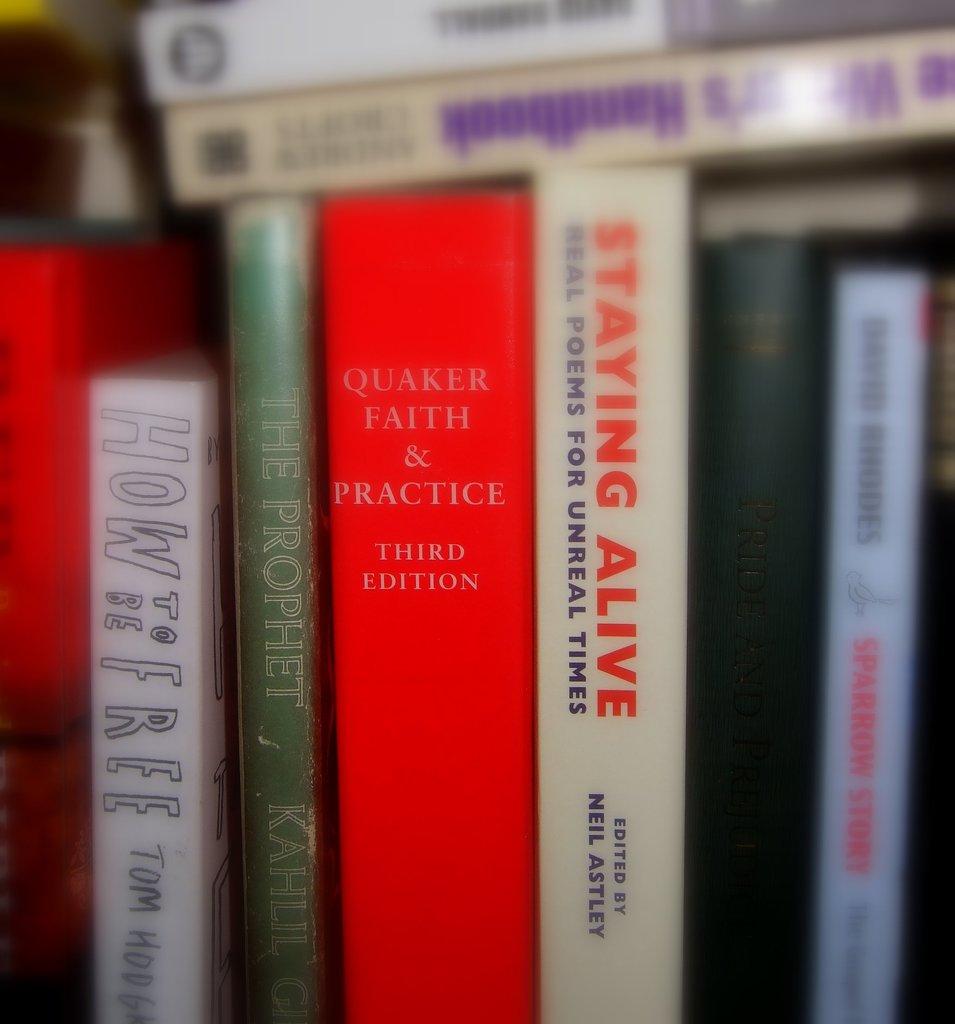What is the title of the red book?
Offer a terse response. Quaker faith & practice third edition. Who edited staying alive?
Keep it short and to the point. Neil astley. 